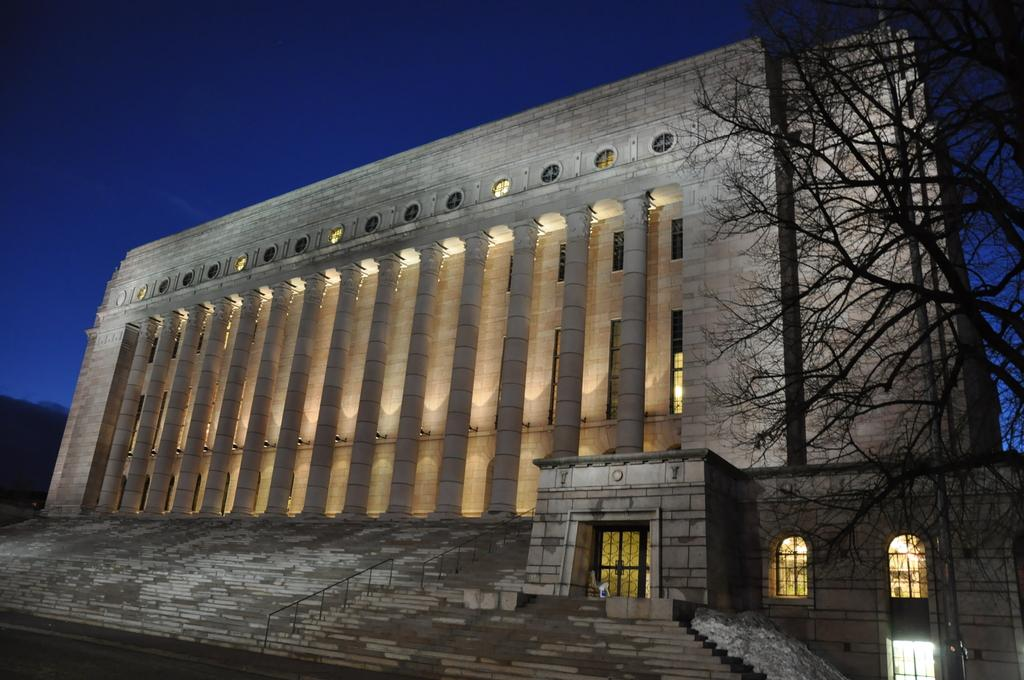What type of structure is present in the image? There is a building in the image. What architectural feature can be seen on the building? The building has pillars. What can be used to access the building in the image? There are steps in the image. What is used for illumination in the image? There are lights visible in the image. What type of vegetation is present in the image? There are trees in the image. How would you describe the overall lighting in the image? The background of the image is dark. What is the income of the bee buzzing around the building in the image? There is no bee present in the image, and therefore no income can be determined. 